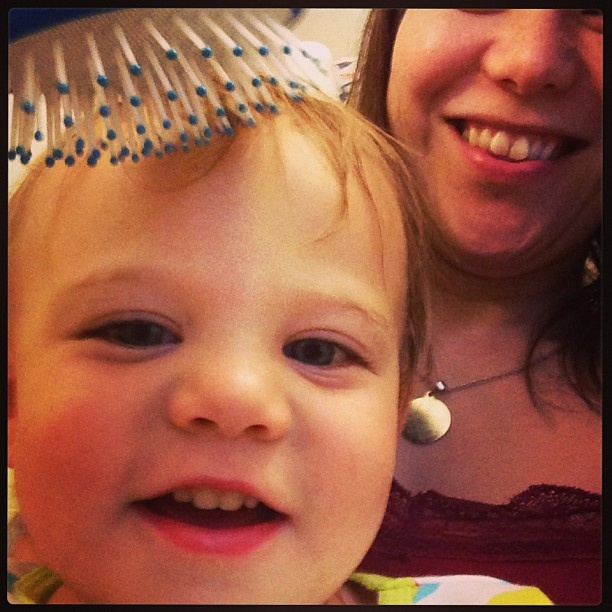Describe the objects in this image and their specific colors. I can see people in black, tan, brown, and salmon tones and people in black, maroon, and brown tones in this image. 